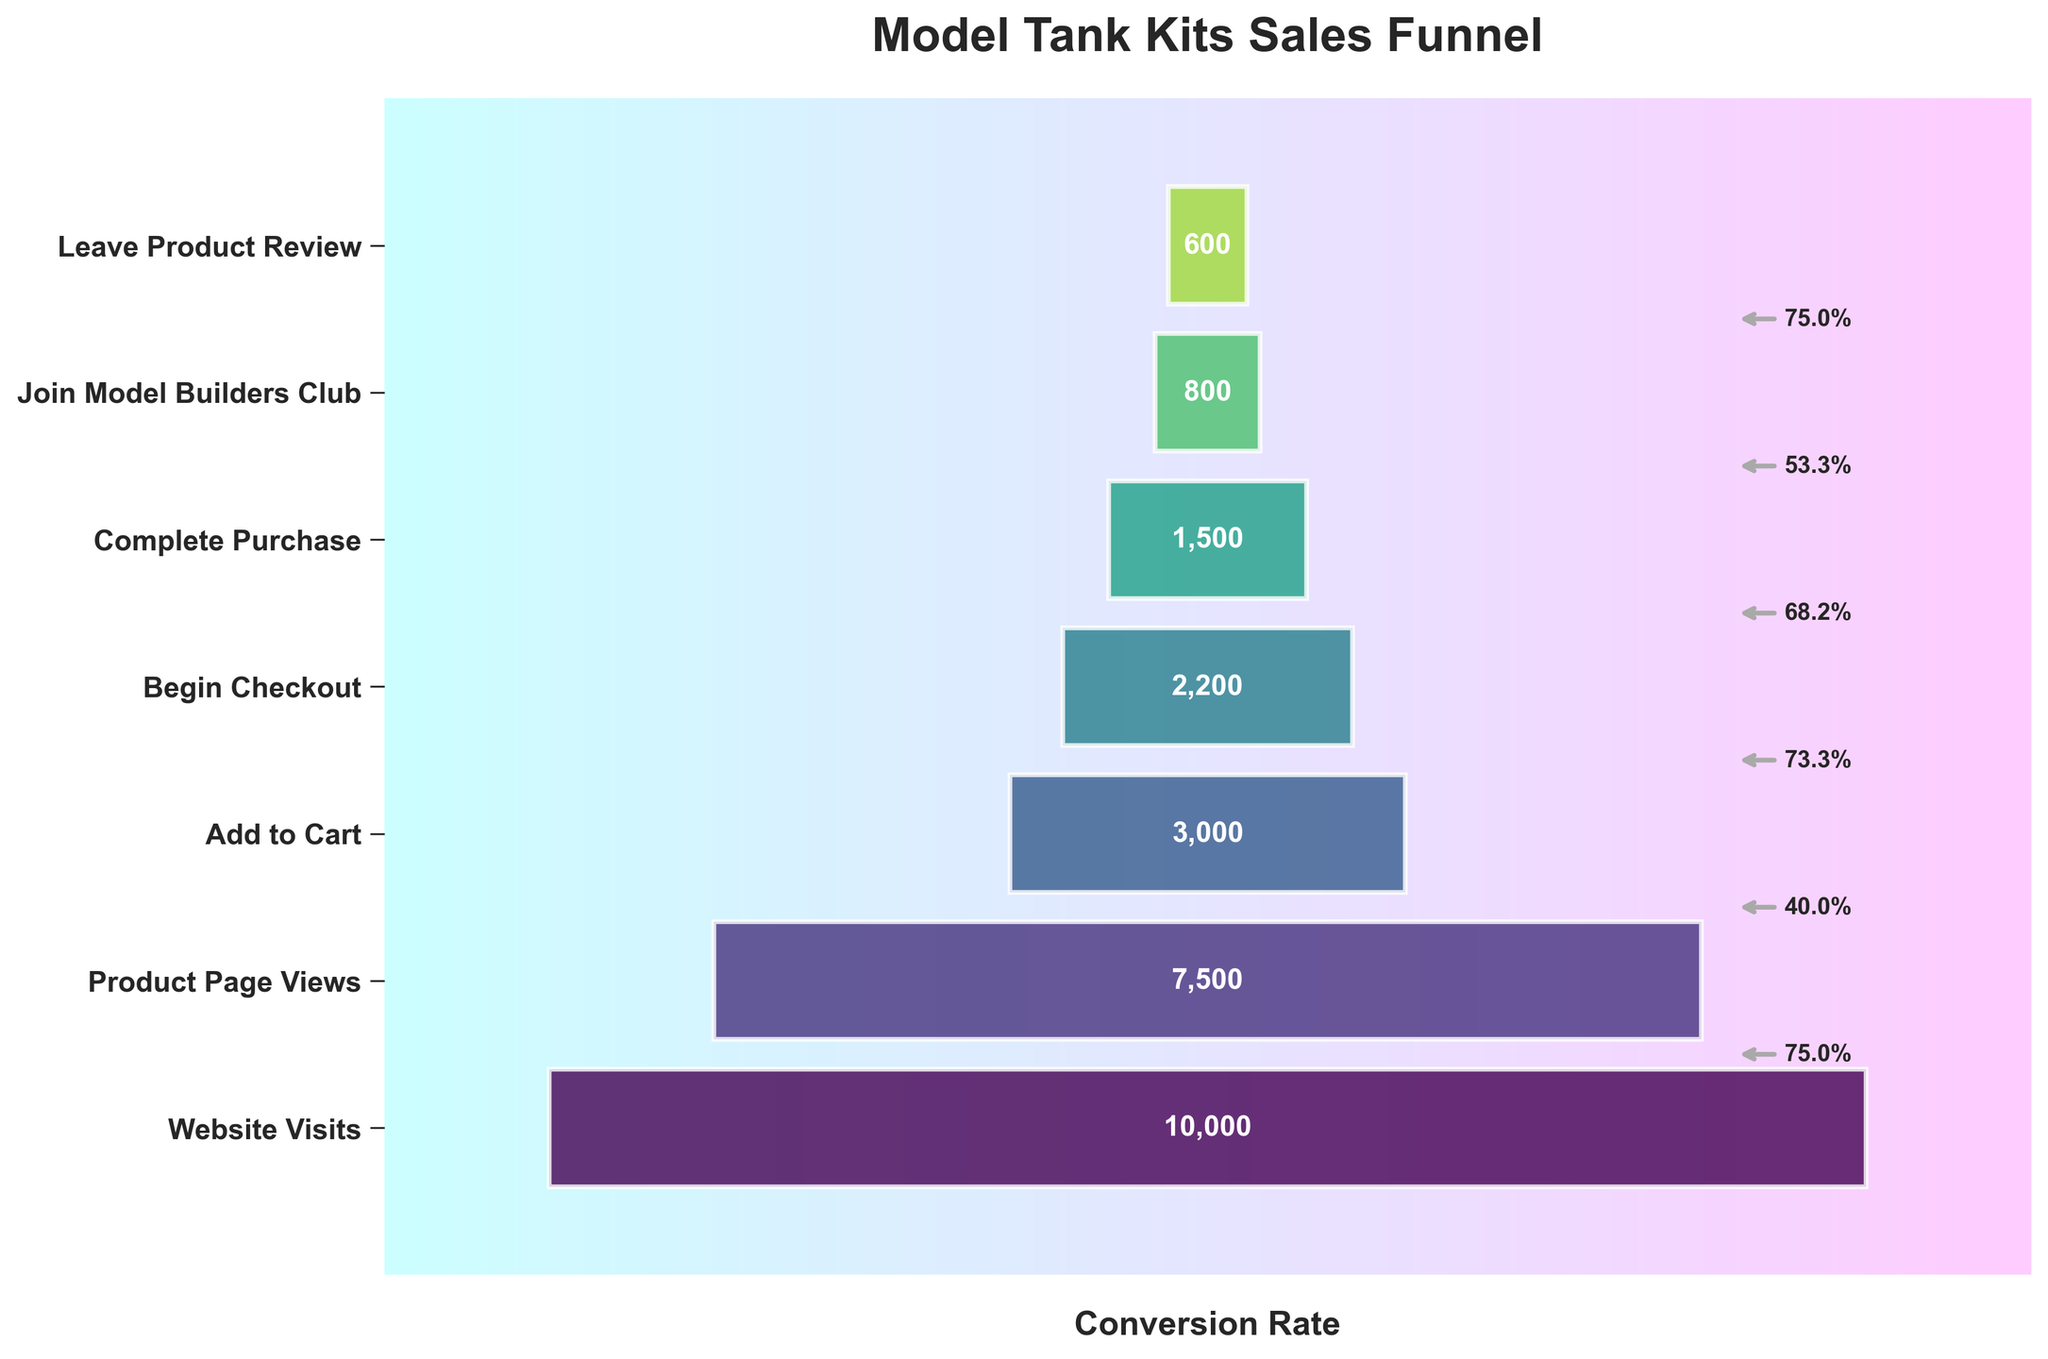What is the total number of website visits shown in the funnel chart? The total number of website visits is directly labeled as 10,000 at the top of the funnel chart.
Answer: 10,000 Which stage has the highest conversion rate from the previous stage? To determine the highest conversion rate, we calculate the percentage for each transition: from Website Visits to Product Page Views is (7500/10000)*100 = 75%, from Product Page Views to Add to Cart is (3000/7500)*100 = 40%, from Add to Cart to Begin Checkout is (2200/3000)*100 = 73.33%, from Begin Checkout to Complete Purchase is (1500/2200)*100 = 68.18%, from Complete Purchase to Join Model Builders Club is (800/1500)*100 = 53.33%, and from Join Model Builders Club to Leave Product Review is (600/800)*100 = 75%. Hence, the highest conversion rate occurs from Join Model Builders Club to Leave Product Review.
Answer: 75% What is the conversion rate from Website Visits to Complete Purchase? To find the conversion rate from Website Visits to Complete Purchase, divide the Complete Purchase count by the Website Visits count and multiply by 100: (1500/10000)*100 = 15%.
Answer: 15% How many more people viewed the product page compared to those who completed a purchase? Subtract the number of Complete Purchases from the number of Product Page Views: 7500 - 1500 = 6000.
Answer: 6000 By what percentage did the count decrease from Add to Cart to Begin Checkout? To find the percentage decrease, subtract the number of Begin Checkouts from Add to Cart, divide by the Add to Cart number, and multiply by 100: (3000 - 2200) / 3000 * 100 = 26.67%.
Answer: 26.67% How many steps are there in the sales funnel? Count the number of distinct stages displayed in the funnel chart: Website Visits, Product Page Views, Add to Cart, Begin Checkout, Complete Purchase, Join Model Builders Club, Leave Product Review. There are 7 steps.
Answer: 7 Which stage has the lowest count number in the sales funnel? The lowest count number is at the bottom of the funnel, which is for Leave Product Review with 600.
Answer: Leave Product Review What is the average number of counts at each stage of the funnel? Sum all the counts and divide by the number of stages: (10000 + 7500 + 3000 + 2200 + 1500 + 800 + 600) / 7 = 8,1300 / 7 ≈ 3614.29.
Answer: 3614.29 How many people reached Join Model Builders Club after completing a purchase? From the funnel, the number of people who reached Join Model Builders Club is labeled as 800.
Answer: 800 